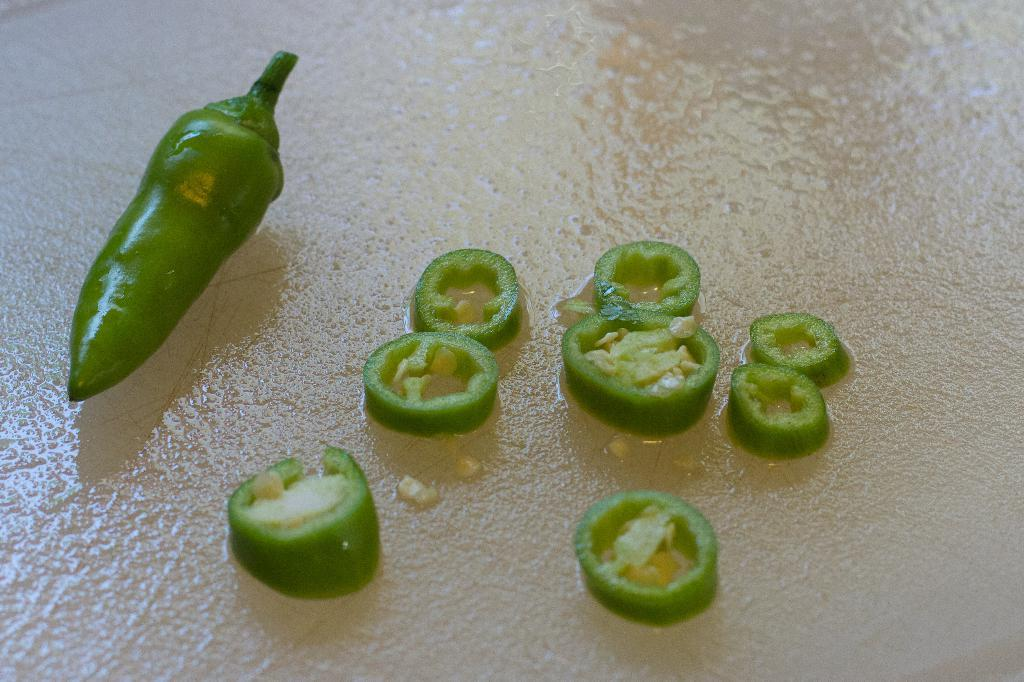What is the main subject of the image? The main subject of the image is a chilli. Are there any additional chilli-related items in the image? Yes, there are chilli pieces in the image. Where are the chilli and chilli pieces located? The chilli and chilli pieces are placed on a table. What type of approval is being given by the clock in the image? There is no clock present in the image, so approval cannot be given by a clock. 